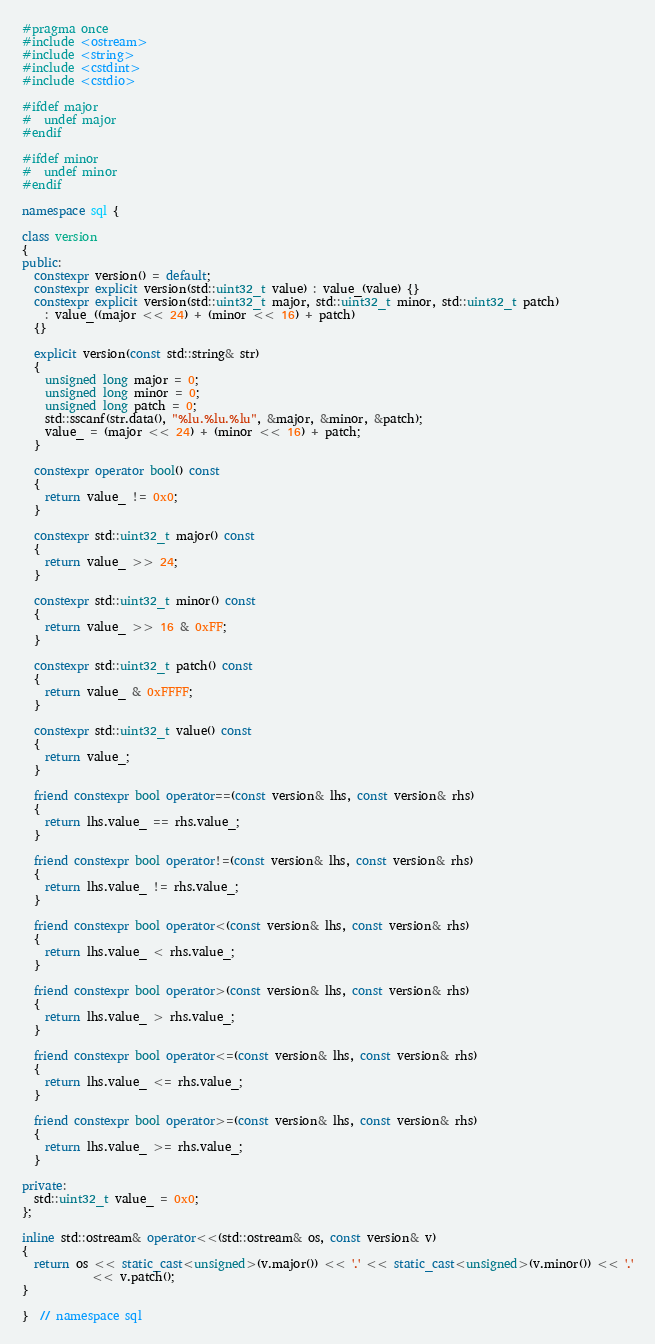Convert code to text. <code><loc_0><loc_0><loc_500><loc_500><_C++_>#pragma once
#include <ostream>
#include <string>
#include <cstdint>
#include <cstdio>

#ifdef major
#  undef major
#endif

#ifdef minor
#  undef minor
#endif

namespace sql {

class version
{
public:
  constexpr version() = default;
  constexpr explicit version(std::uint32_t value) : value_(value) {}
  constexpr explicit version(std::uint32_t major, std::uint32_t minor, std::uint32_t patch)
    : value_((major << 24) + (minor << 16) + patch)
  {}

  explicit version(const std::string& str)
  {
    unsigned long major = 0;
    unsigned long minor = 0;
    unsigned long patch = 0;
    std::sscanf(str.data(), "%lu.%lu.%lu", &major, &minor, &patch);
    value_ = (major << 24) + (minor << 16) + patch;
  }

  constexpr operator bool() const
  {
    return value_ != 0x0;
  }

  constexpr std::uint32_t major() const
  {
    return value_ >> 24;
  }

  constexpr std::uint32_t minor() const
  {
    return value_ >> 16 & 0xFF;
  }

  constexpr std::uint32_t patch() const
  {
    return value_ & 0xFFFF;
  }

  constexpr std::uint32_t value() const
  {
    return value_;
  }

  friend constexpr bool operator==(const version& lhs, const version& rhs)
  {
    return lhs.value_ == rhs.value_;
  }

  friend constexpr bool operator!=(const version& lhs, const version& rhs)
  {
    return lhs.value_ != rhs.value_;
  }

  friend constexpr bool operator<(const version& lhs, const version& rhs)
  {
    return lhs.value_ < rhs.value_;
  }

  friend constexpr bool operator>(const version& lhs, const version& rhs)
  {
    return lhs.value_ > rhs.value_;
  }

  friend constexpr bool operator<=(const version& lhs, const version& rhs)
  {
    return lhs.value_ <= rhs.value_;
  }

  friend constexpr bool operator>=(const version& lhs, const version& rhs)
  {
    return lhs.value_ >= rhs.value_;
  }

private:
  std::uint32_t value_ = 0x0;
};

inline std::ostream& operator<<(std::ostream& os, const version& v)
{
  return os << static_cast<unsigned>(v.major()) << '.' << static_cast<unsigned>(v.minor()) << '.'
            << v.patch();
}

}  // namespace sql
</code> 